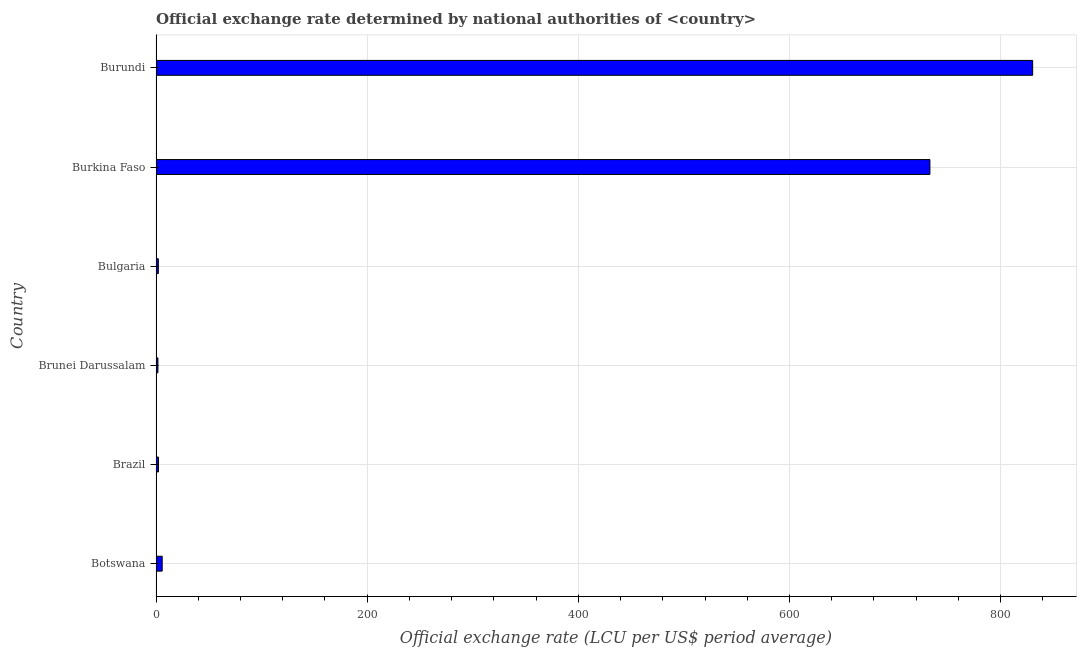What is the title of the graph?
Offer a very short reply. Official exchange rate determined by national authorities of <country>. What is the label or title of the X-axis?
Keep it short and to the point. Official exchange rate (LCU per US$ period average). What is the official exchange rate in Botswana?
Offer a terse response. 5.84. Across all countries, what is the maximum official exchange rate?
Your answer should be compact. 830.35. Across all countries, what is the minimum official exchange rate?
Keep it short and to the point. 1.79. In which country was the official exchange rate maximum?
Make the answer very short. Burundi. In which country was the official exchange rate minimum?
Make the answer very short. Brunei Darussalam. What is the sum of the official exchange rate?
Your answer should be very brief. 1575.56. What is the difference between the official exchange rate in Brunei Darussalam and Burundi?
Keep it short and to the point. -828.56. What is the average official exchange rate per country?
Ensure brevity in your answer.  262.59. What is the median official exchange rate?
Provide a succinct answer. 4.1. In how many countries, is the official exchange rate greater than 440 ?
Keep it short and to the point. 2. What is the ratio of the official exchange rate in Brunei Darussalam to that in Burundi?
Make the answer very short. 0. What is the difference between the highest and the second highest official exchange rate?
Keep it short and to the point. 97.31. Is the sum of the official exchange rate in Brazil and Burkina Faso greater than the maximum official exchange rate across all countries?
Offer a terse response. No. What is the difference between the highest and the lowest official exchange rate?
Keep it short and to the point. 828.56. In how many countries, is the official exchange rate greater than the average official exchange rate taken over all countries?
Make the answer very short. 2. Are all the bars in the graph horizontal?
Keep it short and to the point. Yes. How many countries are there in the graph?
Keep it short and to the point. 6. What is the difference between two consecutive major ticks on the X-axis?
Offer a terse response. 200. Are the values on the major ticks of X-axis written in scientific E-notation?
Make the answer very short. No. What is the Official exchange rate (LCU per US$ period average) in Botswana?
Give a very brief answer. 5.84. What is the Official exchange rate (LCU per US$ period average) of Brazil?
Offer a terse response. 2.35. What is the Official exchange rate (LCU per US$ period average) of Brunei Darussalam?
Your answer should be very brief. 1.79. What is the Official exchange rate (LCU per US$ period average) in Bulgaria?
Offer a terse response. 2.18. What is the Official exchange rate (LCU per US$ period average) in Burkina Faso?
Your answer should be very brief. 733.04. What is the Official exchange rate (LCU per US$ period average) in Burundi?
Your answer should be compact. 830.35. What is the difference between the Official exchange rate (LCU per US$ period average) in Botswana and Brazil?
Make the answer very short. 3.49. What is the difference between the Official exchange rate (LCU per US$ period average) in Botswana and Brunei Darussalam?
Provide a succinct answer. 4.05. What is the difference between the Official exchange rate (LCU per US$ period average) in Botswana and Bulgaria?
Offer a terse response. 3.66. What is the difference between the Official exchange rate (LCU per US$ period average) in Botswana and Burkina Faso?
Your response must be concise. -727.2. What is the difference between the Official exchange rate (LCU per US$ period average) in Botswana and Burundi?
Offer a terse response. -824.51. What is the difference between the Official exchange rate (LCU per US$ period average) in Brazil and Brunei Darussalam?
Provide a short and direct response. 0.56. What is the difference between the Official exchange rate (LCU per US$ period average) in Brazil and Bulgaria?
Provide a short and direct response. 0.16. What is the difference between the Official exchange rate (LCU per US$ period average) in Brazil and Burkina Faso?
Give a very brief answer. -730.69. What is the difference between the Official exchange rate (LCU per US$ period average) in Brazil and Burundi?
Make the answer very short. -828. What is the difference between the Official exchange rate (LCU per US$ period average) in Brunei Darussalam and Bulgaria?
Offer a very short reply. -0.39. What is the difference between the Official exchange rate (LCU per US$ period average) in Brunei Darussalam and Burkina Faso?
Your answer should be compact. -731.25. What is the difference between the Official exchange rate (LCU per US$ period average) in Brunei Darussalam and Burundi?
Your answer should be compact. -828.56. What is the difference between the Official exchange rate (LCU per US$ period average) in Bulgaria and Burkina Faso?
Make the answer very short. -730.85. What is the difference between the Official exchange rate (LCU per US$ period average) in Bulgaria and Burundi?
Provide a short and direct response. -828.17. What is the difference between the Official exchange rate (LCU per US$ period average) in Burkina Faso and Burundi?
Keep it short and to the point. -97.31. What is the ratio of the Official exchange rate (LCU per US$ period average) in Botswana to that in Brazil?
Offer a terse response. 2.49. What is the ratio of the Official exchange rate (LCU per US$ period average) in Botswana to that in Brunei Darussalam?
Give a very brief answer. 3.26. What is the ratio of the Official exchange rate (LCU per US$ period average) in Botswana to that in Bulgaria?
Provide a succinct answer. 2.67. What is the ratio of the Official exchange rate (LCU per US$ period average) in Botswana to that in Burkina Faso?
Your answer should be compact. 0.01. What is the ratio of the Official exchange rate (LCU per US$ period average) in Botswana to that in Burundi?
Make the answer very short. 0.01. What is the ratio of the Official exchange rate (LCU per US$ period average) in Brazil to that in Brunei Darussalam?
Provide a short and direct response. 1.31. What is the ratio of the Official exchange rate (LCU per US$ period average) in Brazil to that in Bulgaria?
Ensure brevity in your answer.  1.07. What is the ratio of the Official exchange rate (LCU per US$ period average) in Brazil to that in Burkina Faso?
Provide a short and direct response. 0. What is the ratio of the Official exchange rate (LCU per US$ period average) in Brazil to that in Burundi?
Keep it short and to the point. 0. What is the ratio of the Official exchange rate (LCU per US$ period average) in Brunei Darussalam to that in Bulgaria?
Your answer should be compact. 0.82. What is the ratio of the Official exchange rate (LCU per US$ period average) in Brunei Darussalam to that in Burkina Faso?
Offer a terse response. 0. What is the ratio of the Official exchange rate (LCU per US$ period average) in Brunei Darussalam to that in Burundi?
Provide a short and direct response. 0. What is the ratio of the Official exchange rate (LCU per US$ period average) in Bulgaria to that in Burkina Faso?
Your response must be concise. 0. What is the ratio of the Official exchange rate (LCU per US$ period average) in Bulgaria to that in Burundi?
Offer a terse response. 0. What is the ratio of the Official exchange rate (LCU per US$ period average) in Burkina Faso to that in Burundi?
Your answer should be very brief. 0.88. 